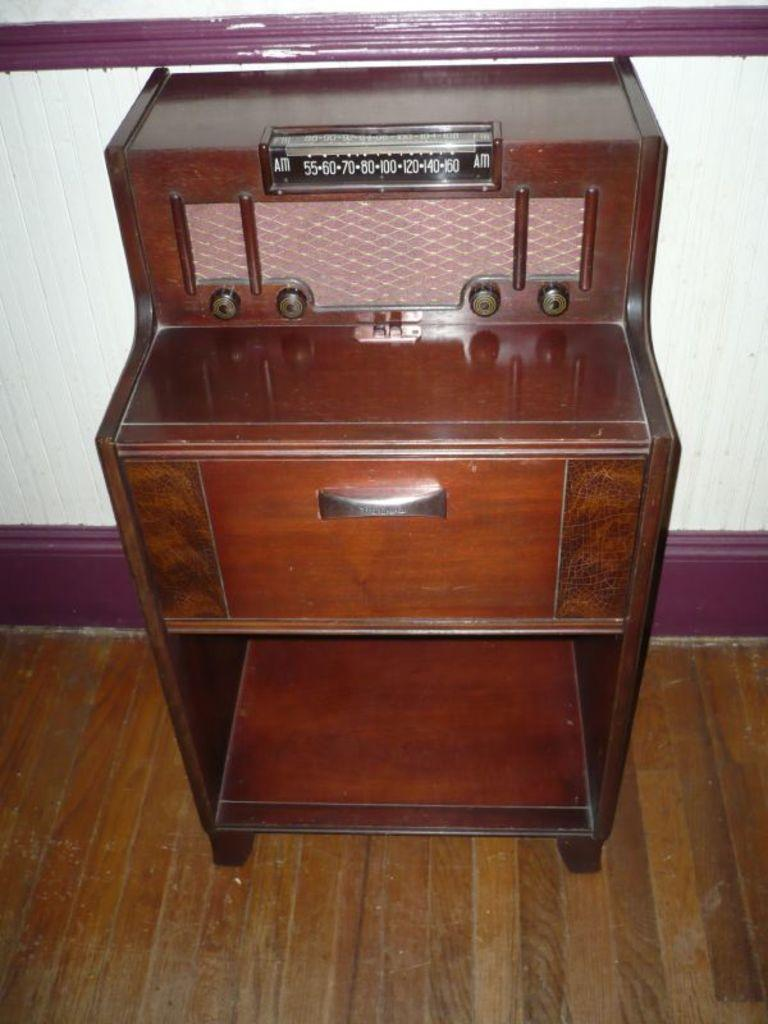What type of table is visible in the image? There is a wooden table in the image. Where is the wooden table located? The wooden table is on the floor. What type of volleyball is being played on the wooden table in the image? There is no volleyball being played on the wooden table in the image. What type of lumber was used to construct the wooden table in the image? The type of lumber used to construct the wooden table cannot be determined from the image. 